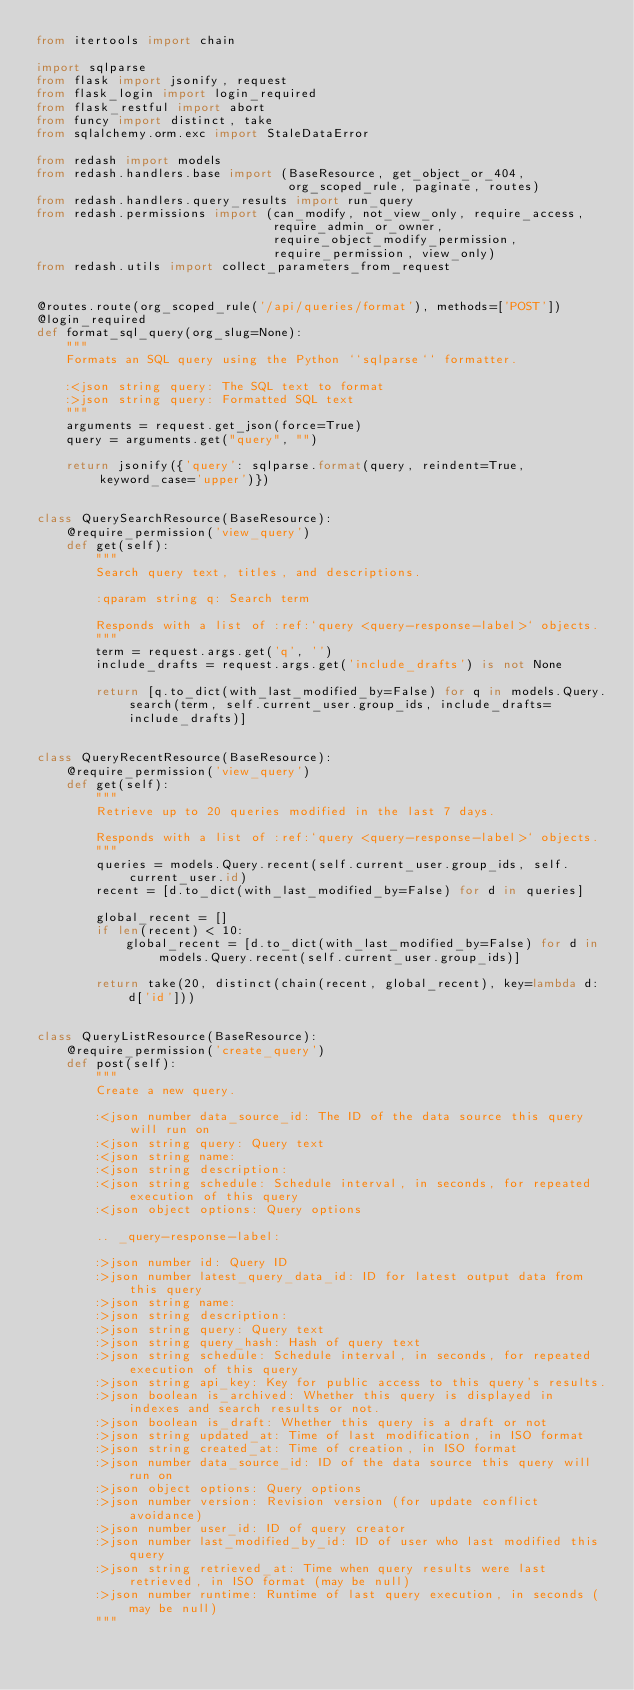Convert code to text. <code><loc_0><loc_0><loc_500><loc_500><_Python_>from itertools import chain

import sqlparse
from flask import jsonify, request
from flask_login import login_required
from flask_restful import abort
from funcy import distinct, take
from sqlalchemy.orm.exc import StaleDataError

from redash import models
from redash.handlers.base import (BaseResource, get_object_or_404,
                                  org_scoped_rule, paginate, routes)
from redash.handlers.query_results import run_query
from redash.permissions import (can_modify, not_view_only, require_access,
                                require_admin_or_owner,
                                require_object_modify_permission,
                                require_permission, view_only)
from redash.utils import collect_parameters_from_request


@routes.route(org_scoped_rule('/api/queries/format'), methods=['POST'])
@login_required
def format_sql_query(org_slug=None):
    """
    Formats an SQL query using the Python ``sqlparse`` formatter.

    :<json string query: The SQL text to format
    :>json string query: Formatted SQL text
    """
    arguments = request.get_json(force=True)
    query = arguments.get("query", "")

    return jsonify({'query': sqlparse.format(query, reindent=True, keyword_case='upper')})


class QuerySearchResource(BaseResource):
    @require_permission('view_query')
    def get(self):
        """
        Search query text, titles, and descriptions.

        :qparam string q: Search term

        Responds with a list of :ref:`query <query-response-label>` objects.
        """
        term = request.args.get('q', '')
        include_drafts = request.args.get('include_drafts') is not None

        return [q.to_dict(with_last_modified_by=False) for q in models.Query.search(term, self.current_user.group_ids, include_drafts=include_drafts)]


class QueryRecentResource(BaseResource):
    @require_permission('view_query')
    def get(self):
        """
        Retrieve up to 20 queries modified in the last 7 days.

        Responds with a list of :ref:`query <query-response-label>` objects.
        """
        queries = models.Query.recent(self.current_user.group_ids, self.current_user.id)
        recent = [d.to_dict(with_last_modified_by=False) for d in queries]

        global_recent = []
        if len(recent) < 10:
            global_recent = [d.to_dict(with_last_modified_by=False) for d in models.Query.recent(self.current_user.group_ids)]

        return take(20, distinct(chain(recent, global_recent), key=lambda d: d['id']))


class QueryListResource(BaseResource):
    @require_permission('create_query')
    def post(self):
        """
        Create a new query.

        :<json number data_source_id: The ID of the data source this query will run on
        :<json string query: Query text
        :<json string name:
        :<json string description:
        :<json string schedule: Schedule interval, in seconds, for repeated execution of this query
        :<json object options: Query options

        .. _query-response-label:

        :>json number id: Query ID
        :>json number latest_query_data_id: ID for latest output data from this query
        :>json string name:
        :>json string description:
        :>json string query: Query text
        :>json string query_hash: Hash of query text
        :>json string schedule: Schedule interval, in seconds, for repeated execution of this query
        :>json string api_key: Key for public access to this query's results.
        :>json boolean is_archived: Whether this query is displayed in indexes and search results or not.
        :>json boolean is_draft: Whether this query is a draft or not
        :>json string updated_at: Time of last modification, in ISO format
        :>json string created_at: Time of creation, in ISO format
        :>json number data_source_id: ID of the data source this query will run on
        :>json object options: Query options
        :>json number version: Revision version (for update conflict avoidance)
        :>json number user_id: ID of query creator
        :>json number last_modified_by_id: ID of user who last modified this query
        :>json string retrieved_at: Time when query results were last retrieved, in ISO format (may be null)
        :>json number runtime: Runtime of last query execution, in seconds (may be null)
        """</code> 